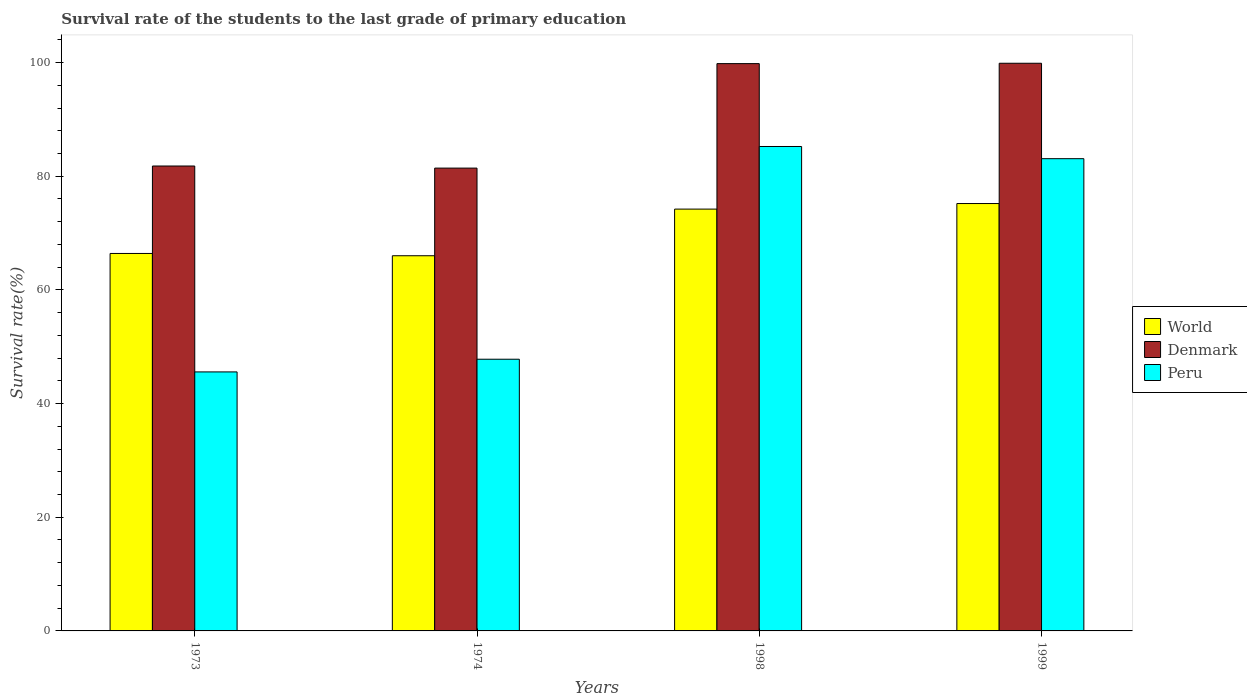How many different coloured bars are there?
Offer a terse response. 3. How many groups of bars are there?
Provide a short and direct response. 4. How many bars are there on the 2nd tick from the left?
Your answer should be very brief. 3. What is the label of the 1st group of bars from the left?
Your response must be concise. 1973. What is the survival rate of the students in Denmark in 1999?
Offer a terse response. 99.88. Across all years, what is the maximum survival rate of the students in Denmark?
Your response must be concise. 99.88. Across all years, what is the minimum survival rate of the students in Denmark?
Your answer should be compact. 81.43. In which year was the survival rate of the students in World minimum?
Keep it short and to the point. 1974. What is the total survival rate of the students in Peru in the graph?
Offer a terse response. 261.7. What is the difference between the survival rate of the students in Peru in 1974 and that in 1999?
Provide a succinct answer. -35.28. What is the difference between the survival rate of the students in World in 1973 and the survival rate of the students in Peru in 1974?
Provide a short and direct response. 18.61. What is the average survival rate of the students in Denmark per year?
Your response must be concise. 90.73. In the year 1973, what is the difference between the survival rate of the students in Denmark and survival rate of the students in Peru?
Provide a succinct answer. 36.23. What is the ratio of the survival rate of the students in Peru in 1998 to that in 1999?
Provide a short and direct response. 1.03. Is the survival rate of the students in World in 1973 less than that in 1999?
Offer a very short reply. Yes. Is the difference between the survival rate of the students in Denmark in 1973 and 1999 greater than the difference between the survival rate of the students in Peru in 1973 and 1999?
Give a very brief answer. Yes. What is the difference between the highest and the second highest survival rate of the students in Peru?
Your answer should be very brief. 2.15. What is the difference between the highest and the lowest survival rate of the students in World?
Ensure brevity in your answer.  9.18. In how many years, is the survival rate of the students in World greater than the average survival rate of the students in World taken over all years?
Your answer should be compact. 2. Is the sum of the survival rate of the students in World in 1973 and 1999 greater than the maximum survival rate of the students in Peru across all years?
Offer a very short reply. Yes. What does the 3rd bar from the left in 1974 represents?
Keep it short and to the point. Peru. What does the 1st bar from the right in 1999 represents?
Give a very brief answer. Peru. How many bars are there?
Give a very brief answer. 12. Are all the bars in the graph horizontal?
Give a very brief answer. No. How many years are there in the graph?
Make the answer very short. 4. What is the difference between two consecutive major ticks on the Y-axis?
Your response must be concise. 20. Are the values on the major ticks of Y-axis written in scientific E-notation?
Your answer should be compact. No. Does the graph contain any zero values?
Provide a succinct answer. No. Does the graph contain grids?
Provide a short and direct response. No. What is the title of the graph?
Ensure brevity in your answer.  Survival rate of the students to the last grade of primary education. What is the label or title of the Y-axis?
Your answer should be very brief. Survival rate(%). What is the Survival rate(%) in World in 1973?
Give a very brief answer. 66.41. What is the Survival rate(%) of Denmark in 1973?
Give a very brief answer. 81.8. What is the Survival rate(%) of Peru in 1973?
Give a very brief answer. 45.57. What is the Survival rate(%) in World in 1974?
Keep it short and to the point. 66.01. What is the Survival rate(%) in Denmark in 1974?
Your answer should be very brief. 81.43. What is the Survival rate(%) of Peru in 1974?
Your answer should be very brief. 47.8. What is the Survival rate(%) in World in 1998?
Make the answer very short. 74.22. What is the Survival rate(%) in Denmark in 1998?
Give a very brief answer. 99.81. What is the Survival rate(%) in Peru in 1998?
Offer a very short reply. 85.23. What is the Survival rate(%) of World in 1999?
Offer a very short reply. 75.2. What is the Survival rate(%) in Denmark in 1999?
Provide a short and direct response. 99.88. What is the Survival rate(%) in Peru in 1999?
Give a very brief answer. 83.09. Across all years, what is the maximum Survival rate(%) in World?
Give a very brief answer. 75.2. Across all years, what is the maximum Survival rate(%) of Denmark?
Provide a short and direct response. 99.88. Across all years, what is the maximum Survival rate(%) of Peru?
Your answer should be compact. 85.23. Across all years, what is the minimum Survival rate(%) of World?
Your answer should be compact. 66.01. Across all years, what is the minimum Survival rate(%) of Denmark?
Your response must be concise. 81.43. Across all years, what is the minimum Survival rate(%) of Peru?
Your response must be concise. 45.57. What is the total Survival rate(%) of World in the graph?
Give a very brief answer. 281.83. What is the total Survival rate(%) in Denmark in the graph?
Offer a terse response. 362.92. What is the total Survival rate(%) in Peru in the graph?
Give a very brief answer. 261.7. What is the difference between the Survival rate(%) of World in 1973 and that in 1974?
Provide a succinct answer. 0.4. What is the difference between the Survival rate(%) of Denmark in 1973 and that in 1974?
Your answer should be very brief. 0.37. What is the difference between the Survival rate(%) of Peru in 1973 and that in 1974?
Your answer should be compact. -2.23. What is the difference between the Survival rate(%) in World in 1973 and that in 1998?
Your answer should be very brief. -7.8. What is the difference between the Survival rate(%) of Denmark in 1973 and that in 1998?
Your answer should be very brief. -18.01. What is the difference between the Survival rate(%) of Peru in 1973 and that in 1998?
Your response must be concise. -39.66. What is the difference between the Survival rate(%) in World in 1973 and that in 1999?
Your response must be concise. -8.78. What is the difference between the Survival rate(%) of Denmark in 1973 and that in 1999?
Ensure brevity in your answer.  -18.08. What is the difference between the Survival rate(%) in Peru in 1973 and that in 1999?
Provide a succinct answer. -37.52. What is the difference between the Survival rate(%) in World in 1974 and that in 1998?
Your response must be concise. -8.21. What is the difference between the Survival rate(%) of Denmark in 1974 and that in 1998?
Your answer should be compact. -18.38. What is the difference between the Survival rate(%) in Peru in 1974 and that in 1998?
Make the answer very short. -37.43. What is the difference between the Survival rate(%) of World in 1974 and that in 1999?
Offer a terse response. -9.18. What is the difference between the Survival rate(%) of Denmark in 1974 and that in 1999?
Offer a very short reply. -18.45. What is the difference between the Survival rate(%) of Peru in 1974 and that in 1999?
Your answer should be compact. -35.28. What is the difference between the Survival rate(%) of World in 1998 and that in 1999?
Make the answer very short. -0.98. What is the difference between the Survival rate(%) of Denmark in 1998 and that in 1999?
Your answer should be very brief. -0.06. What is the difference between the Survival rate(%) of Peru in 1998 and that in 1999?
Your answer should be very brief. 2.15. What is the difference between the Survival rate(%) in World in 1973 and the Survival rate(%) in Denmark in 1974?
Provide a succinct answer. -15.02. What is the difference between the Survival rate(%) in World in 1973 and the Survival rate(%) in Peru in 1974?
Provide a short and direct response. 18.61. What is the difference between the Survival rate(%) of Denmark in 1973 and the Survival rate(%) of Peru in 1974?
Offer a terse response. 34. What is the difference between the Survival rate(%) of World in 1973 and the Survival rate(%) of Denmark in 1998?
Your answer should be compact. -33.4. What is the difference between the Survival rate(%) in World in 1973 and the Survival rate(%) in Peru in 1998?
Your response must be concise. -18.82. What is the difference between the Survival rate(%) of Denmark in 1973 and the Survival rate(%) of Peru in 1998?
Ensure brevity in your answer.  -3.43. What is the difference between the Survival rate(%) in World in 1973 and the Survival rate(%) in Denmark in 1999?
Your response must be concise. -33.46. What is the difference between the Survival rate(%) of World in 1973 and the Survival rate(%) of Peru in 1999?
Give a very brief answer. -16.68. What is the difference between the Survival rate(%) of Denmark in 1973 and the Survival rate(%) of Peru in 1999?
Offer a very short reply. -1.29. What is the difference between the Survival rate(%) in World in 1974 and the Survival rate(%) in Denmark in 1998?
Provide a short and direct response. -33.8. What is the difference between the Survival rate(%) of World in 1974 and the Survival rate(%) of Peru in 1998?
Make the answer very short. -19.22. What is the difference between the Survival rate(%) in Denmark in 1974 and the Survival rate(%) in Peru in 1998?
Your response must be concise. -3.8. What is the difference between the Survival rate(%) of World in 1974 and the Survival rate(%) of Denmark in 1999?
Provide a succinct answer. -33.86. What is the difference between the Survival rate(%) of World in 1974 and the Survival rate(%) of Peru in 1999?
Make the answer very short. -17.08. What is the difference between the Survival rate(%) in Denmark in 1974 and the Survival rate(%) in Peru in 1999?
Give a very brief answer. -1.66. What is the difference between the Survival rate(%) of World in 1998 and the Survival rate(%) of Denmark in 1999?
Your response must be concise. -25.66. What is the difference between the Survival rate(%) in World in 1998 and the Survival rate(%) in Peru in 1999?
Your response must be concise. -8.87. What is the difference between the Survival rate(%) in Denmark in 1998 and the Survival rate(%) in Peru in 1999?
Your response must be concise. 16.72. What is the average Survival rate(%) in World per year?
Keep it short and to the point. 70.46. What is the average Survival rate(%) of Denmark per year?
Provide a succinct answer. 90.73. What is the average Survival rate(%) in Peru per year?
Your answer should be compact. 65.42. In the year 1973, what is the difference between the Survival rate(%) of World and Survival rate(%) of Denmark?
Keep it short and to the point. -15.39. In the year 1973, what is the difference between the Survival rate(%) in World and Survival rate(%) in Peru?
Give a very brief answer. 20.84. In the year 1973, what is the difference between the Survival rate(%) of Denmark and Survival rate(%) of Peru?
Keep it short and to the point. 36.23. In the year 1974, what is the difference between the Survival rate(%) of World and Survival rate(%) of Denmark?
Your answer should be very brief. -15.42. In the year 1974, what is the difference between the Survival rate(%) in World and Survival rate(%) in Peru?
Give a very brief answer. 18.21. In the year 1974, what is the difference between the Survival rate(%) of Denmark and Survival rate(%) of Peru?
Offer a terse response. 33.63. In the year 1998, what is the difference between the Survival rate(%) in World and Survival rate(%) in Denmark?
Provide a succinct answer. -25.6. In the year 1998, what is the difference between the Survival rate(%) in World and Survival rate(%) in Peru?
Provide a succinct answer. -11.02. In the year 1998, what is the difference between the Survival rate(%) in Denmark and Survival rate(%) in Peru?
Offer a terse response. 14.58. In the year 1999, what is the difference between the Survival rate(%) of World and Survival rate(%) of Denmark?
Offer a terse response. -24.68. In the year 1999, what is the difference between the Survival rate(%) of World and Survival rate(%) of Peru?
Your answer should be compact. -7.89. In the year 1999, what is the difference between the Survival rate(%) of Denmark and Survival rate(%) of Peru?
Make the answer very short. 16.79. What is the ratio of the Survival rate(%) in World in 1973 to that in 1974?
Your response must be concise. 1.01. What is the ratio of the Survival rate(%) in Peru in 1973 to that in 1974?
Provide a short and direct response. 0.95. What is the ratio of the Survival rate(%) of World in 1973 to that in 1998?
Keep it short and to the point. 0.89. What is the ratio of the Survival rate(%) in Denmark in 1973 to that in 1998?
Offer a terse response. 0.82. What is the ratio of the Survival rate(%) of Peru in 1973 to that in 1998?
Give a very brief answer. 0.53. What is the ratio of the Survival rate(%) in World in 1973 to that in 1999?
Ensure brevity in your answer.  0.88. What is the ratio of the Survival rate(%) in Denmark in 1973 to that in 1999?
Ensure brevity in your answer.  0.82. What is the ratio of the Survival rate(%) of Peru in 1973 to that in 1999?
Give a very brief answer. 0.55. What is the ratio of the Survival rate(%) of World in 1974 to that in 1998?
Provide a short and direct response. 0.89. What is the ratio of the Survival rate(%) in Denmark in 1974 to that in 1998?
Give a very brief answer. 0.82. What is the ratio of the Survival rate(%) of Peru in 1974 to that in 1998?
Offer a terse response. 0.56. What is the ratio of the Survival rate(%) in World in 1974 to that in 1999?
Your answer should be compact. 0.88. What is the ratio of the Survival rate(%) in Denmark in 1974 to that in 1999?
Provide a short and direct response. 0.82. What is the ratio of the Survival rate(%) of Peru in 1974 to that in 1999?
Offer a terse response. 0.58. What is the ratio of the Survival rate(%) of Denmark in 1998 to that in 1999?
Ensure brevity in your answer.  1. What is the ratio of the Survival rate(%) in Peru in 1998 to that in 1999?
Keep it short and to the point. 1.03. What is the difference between the highest and the second highest Survival rate(%) in World?
Your answer should be very brief. 0.98. What is the difference between the highest and the second highest Survival rate(%) in Denmark?
Provide a succinct answer. 0.06. What is the difference between the highest and the second highest Survival rate(%) of Peru?
Make the answer very short. 2.15. What is the difference between the highest and the lowest Survival rate(%) in World?
Offer a very short reply. 9.18. What is the difference between the highest and the lowest Survival rate(%) in Denmark?
Your response must be concise. 18.45. What is the difference between the highest and the lowest Survival rate(%) in Peru?
Give a very brief answer. 39.66. 